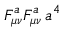<formula> <loc_0><loc_0><loc_500><loc_500>F _ { \mu \nu } ^ { a } F _ { \mu \nu } ^ { a } \, a ^ { 4 }</formula> 